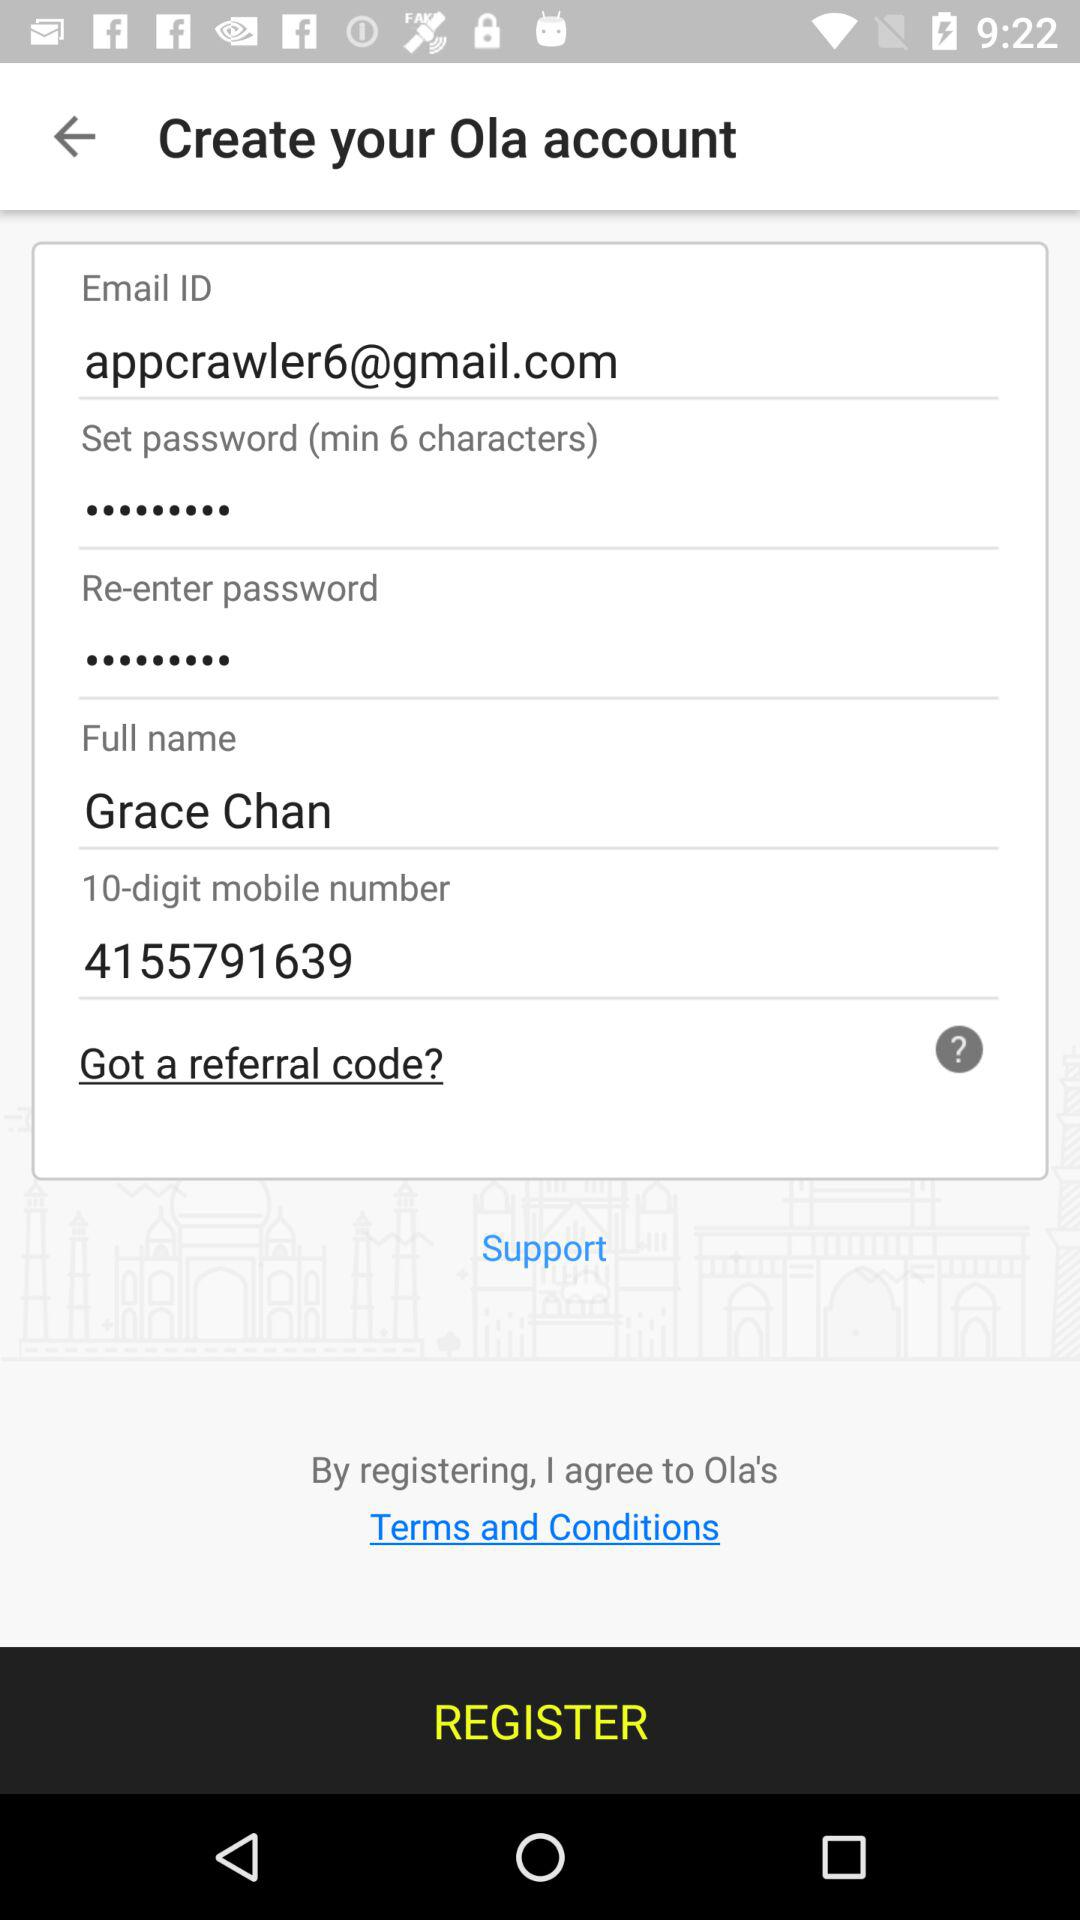What is the 10-digit mobile number? The 10-digit mobile number is 4155791639. 